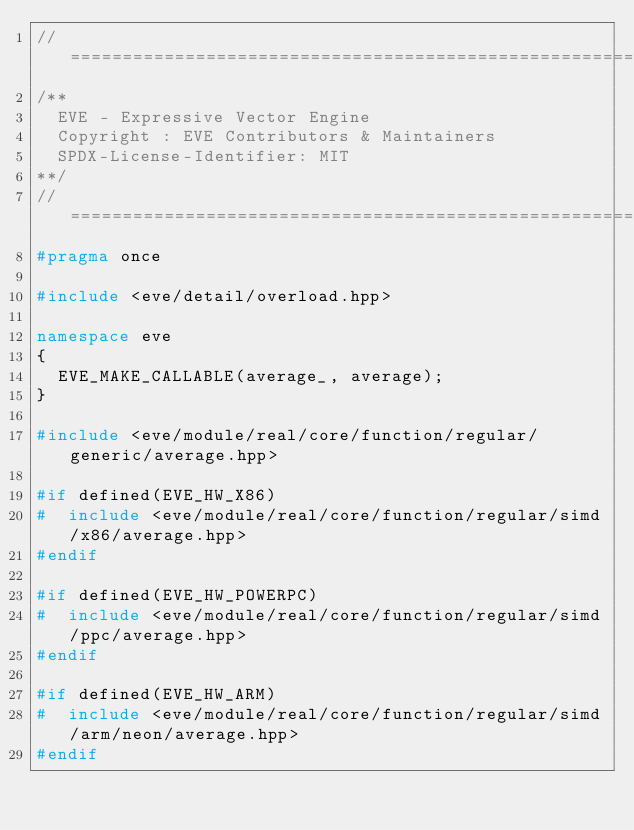Convert code to text. <code><loc_0><loc_0><loc_500><loc_500><_C++_>//==================================================================================================
/**
  EVE - Expressive Vector Engine
  Copyright : EVE Contributors & Maintainers
  SPDX-License-Identifier: MIT
**/
//==================================================================================================
#pragma once

#include <eve/detail/overload.hpp>

namespace eve
{
  EVE_MAKE_CALLABLE(average_, average);
}

#include <eve/module/real/core/function/regular/generic/average.hpp>

#if defined(EVE_HW_X86)
#  include <eve/module/real/core/function/regular/simd/x86/average.hpp>
#endif

#if defined(EVE_HW_POWERPC)
#  include <eve/module/real/core/function/regular/simd/ppc/average.hpp>
#endif

#if defined(EVE_HW_ARM)
#  include <eve/module/real/core/function/regular/simd/arm/neon/average.hpp>
#endif

</code> 